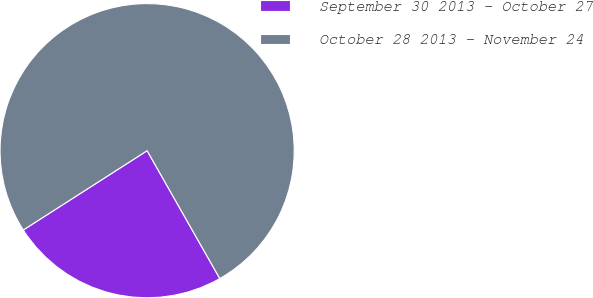Convert chart to OTSL. <chart><loc_0><loc_0><loc_500><loc_500><pie_chart><fcel>September 30 2013 - October 27<fcel>October 28 2013 - November 24<nl><fcel>24.16%<fcel>75.84%<nl></chart> 